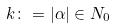<formula> <loc_0><loc_0><loc_500><loc_500>k \colon = | \alpha | \in N _ { 0 }</formula> 